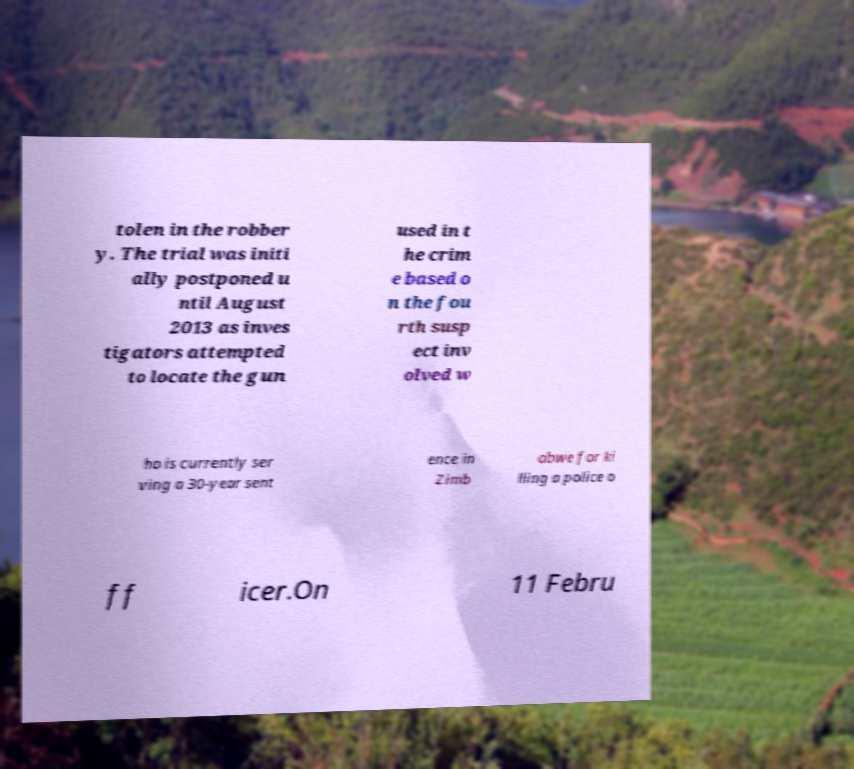Please read and relay the text visible in this image. What does it say? tolen in the robber y. The trial was initi ally postponed u ntil August 2013 as inves tigators attempted to locate the gun used in t he crim e based o n the fou rth susp ect inv olved w ho is currently ser ving a 30-year sent ence in Zimb abwe for ki lling a police o ff icer.On 11 Febru 